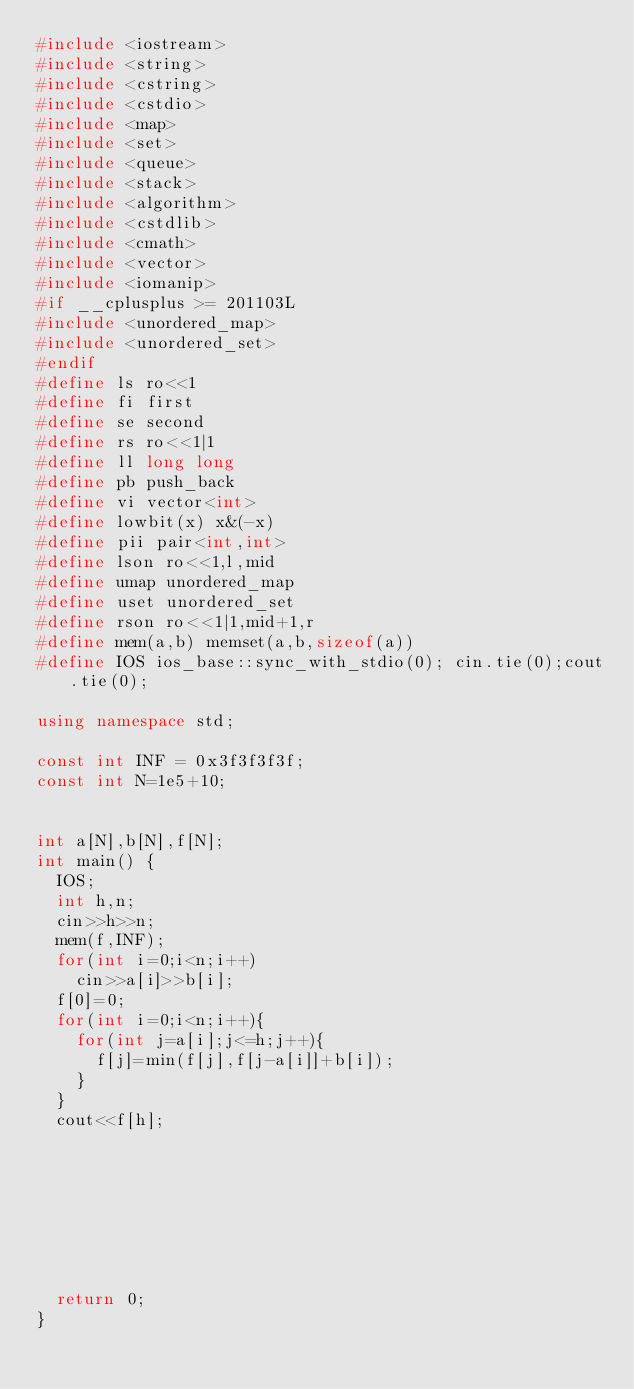Convert code to text. <code><loc_0><loc_0><loc_500><loc_500><_C++_>#include <iostream>
#include <string>
#include <cstring>
#include <cstdio>
#include <map>
#include <set>
#include <queue>
#include <stack>
#include <algorithm>
#include <cstdlib>
#include <cmath>
#include <vector>
#include <iomanip>
#if __cplusplus >= 201103L
#include <unordered_map>
#include <unordered_set>
#endif
#define ls ro<<1
#define fi first
#define se second
#define rs ro<<1|1
#define ll long long
#define pb push_back
#define vi vector<int>
#define lowbit(x) x&(-x)
#define pii pair<int,int>
#define lson ro<<1,l,mid
#define umap unordered_map
#define uset unordered_set
#define rson ro<<1|1,mid+1,r
#define mem(a,b) memset(a,b,sizeof(a))
#define IOS ios_base::sync_with_stdio(0); cin.tie(0);cout.tie(0);

using namespace std;

const int INF = 0x3f3f3f3f;
const int N=1e5+10;


int a[N],b[N],f[N];
int main() {
	IOS;
	int h,n;
	cin>>h>>n;
	mem(f,INF);
	for(int i=0;i<n;i++)
		cin>>a[i]>>b[i];
	f[0]=0;
	for(int i=0;i<n;i++){
		for(int j=a[i];j<=h;j++){
			f[j]=min(f[j],f[j-a[i]]+b[i]);
		}
	}
	cout<<f[h];
	







	return 0;
}
</code> 